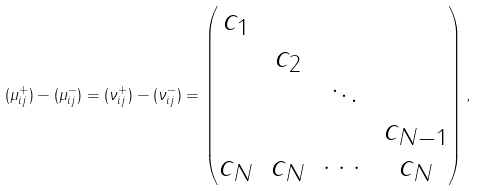Convert formula to latex. <formula><loc_0><loc_0><loc_500><loc_500>( \mu ^ { + } _ { i j } ) - ( \mu ^ { - } _ { i j } ) = ( \nu ^ { + } _ { i j } ) - ( \nu ^ { - } _ { i j } ) = \left ( \begin{matrix} c _ { 1 } \\ & c _ { 2 } \\ & & \ddots \\ & & & c _ { N - 1 } \\ c _ { N } & c _ { N } & \cdots & c _ { N } \end{matrix} \right ) ,</formula> 